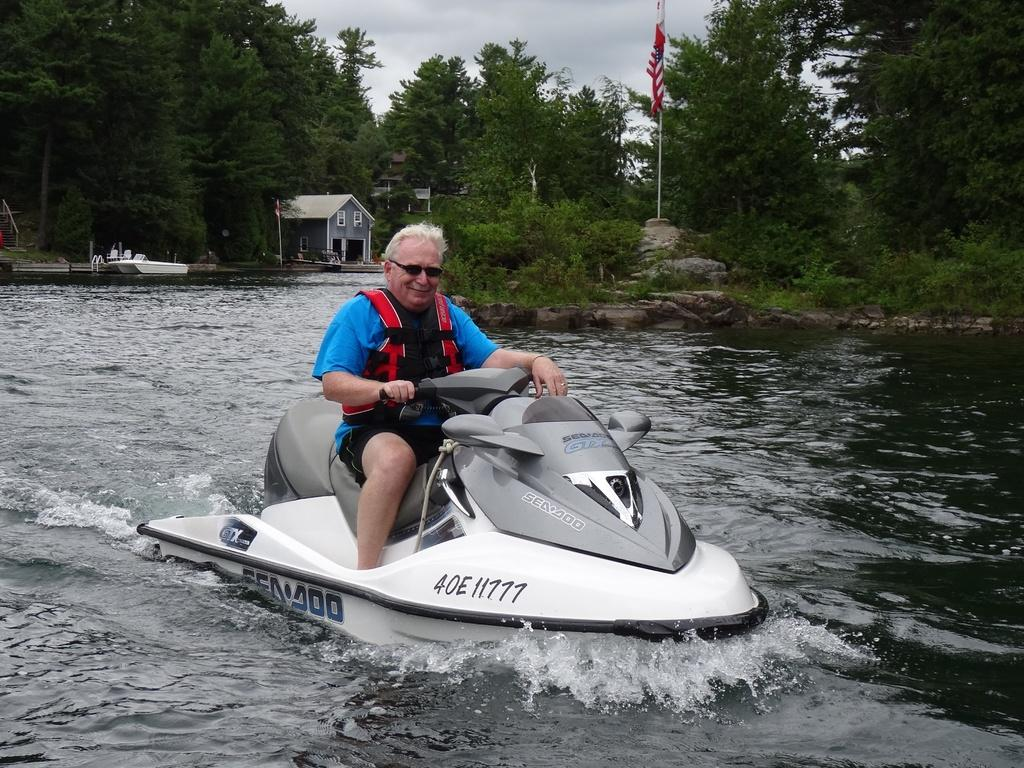<image>
Relay a brief, clear account of the picture shown. A man rides a Sea Doo jet ski across the water. 